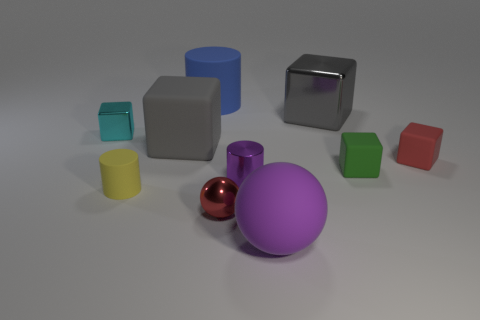What is the size of the gray cube that is in front of the block that is to the left of the large gray rubber thing?
Provide a succinct answer. Large. There is a small matte object that is the same color as the small ball; what shape is it?
Your answer should be compact. Cube. What number of blocks are either tiny red rubber things or cyan matte objects?
Keep it short and to the point. 1. Do the green rubber object and the purple rubber thing that is in front of the small green matte thing have the same size?
Your response must be concise. No. Is the number of red metallic objects that are to the left of the red block greater than the number of large gray spheres?
Make the answer very short. Yes. There is a green cube that is the same material as the yellow thing; what size is it?
Your answer should be very brief. Small. Is there a rubber thing of the same color as the metal cylinder?
Provide a short and direct response. Yes. How many things are gray matte balls or yellow rubber things that are in front of the tiny cyan metallic object?
Provide a short and direct response. 1. Are there more small green rubber objects than matte cylinders?
Your answer should be very brief. No. What is the size of the block that is the same color as the tiny metallic ball?
Offer a terse response. Small. 